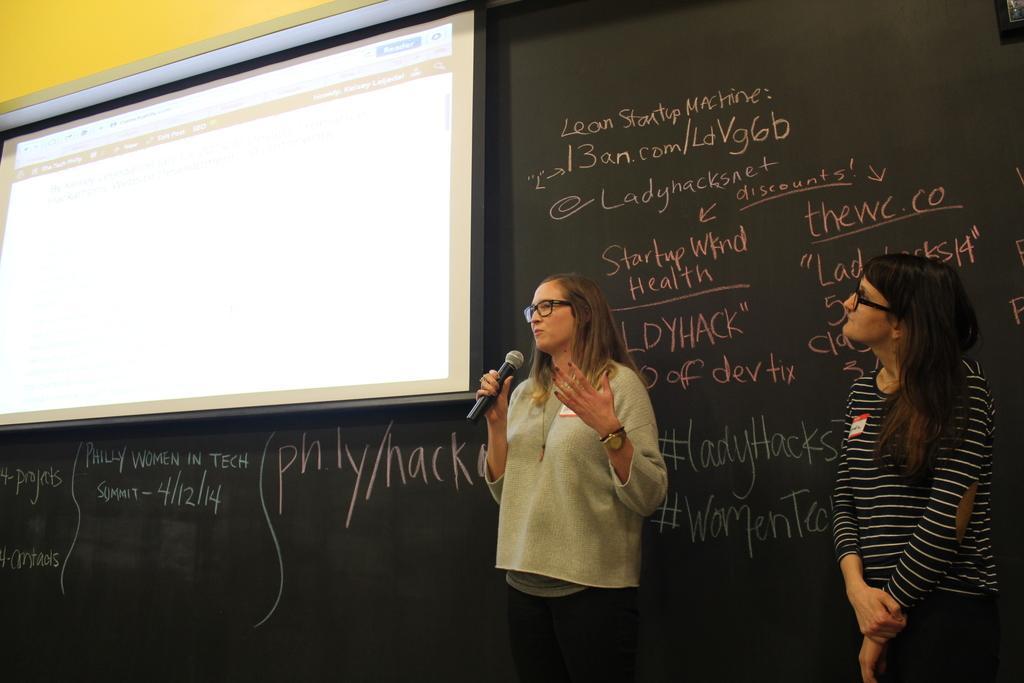In one or two sentences, can you explain what this image depicts? In this image there are two ladies standing. The lady standing in the center is holding a mic. On the left there is a screen placed on the wall and we can see text written. In the background there is a wall. 